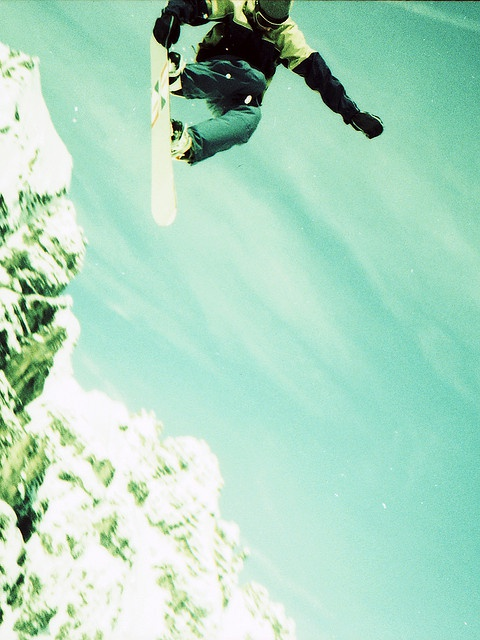Describe the objects in this image and their specific colors. I can see people in aquamarine, black, teal, and turquoise tones and snowboard in aquamarine, beige, khaki, and lightgreen tones in this image. 